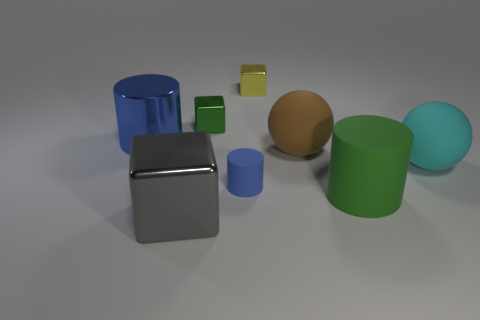Add 1 rubber things. How many objects exist? 9 Subtract all cylinders. How many objects are left? 5 Add 3 large gray objects. How many large gray objects are left? 4 Add 3 tiny blue matte spheres. How many tiny blue matte spheres exist? 3 Subtract 1 yellow cubes. How many objects are left? 7 Subtract all big brown balls. Subtract all cyan objects. How many objects are left? 6 